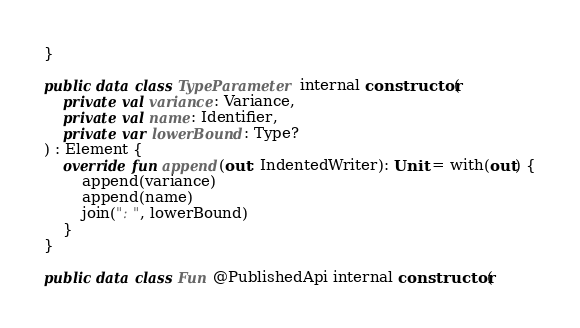Convert code to text. <code><loc_0><loc_0><loc_500><loc_500><_Kotlin_>}

public data class TypeParameter internal constructor(
    private val variance: Variance,
    private val name: Identifier,
    private var lowerBound: Type?
) : Element {
    override fun append(out: IndentedWriter): Unit = with(out) {
        append(variance)
        append(name)
        join(": ", lowerBound)
    }
}

public data class Fun @PublishedApi internal constructor(</code> 